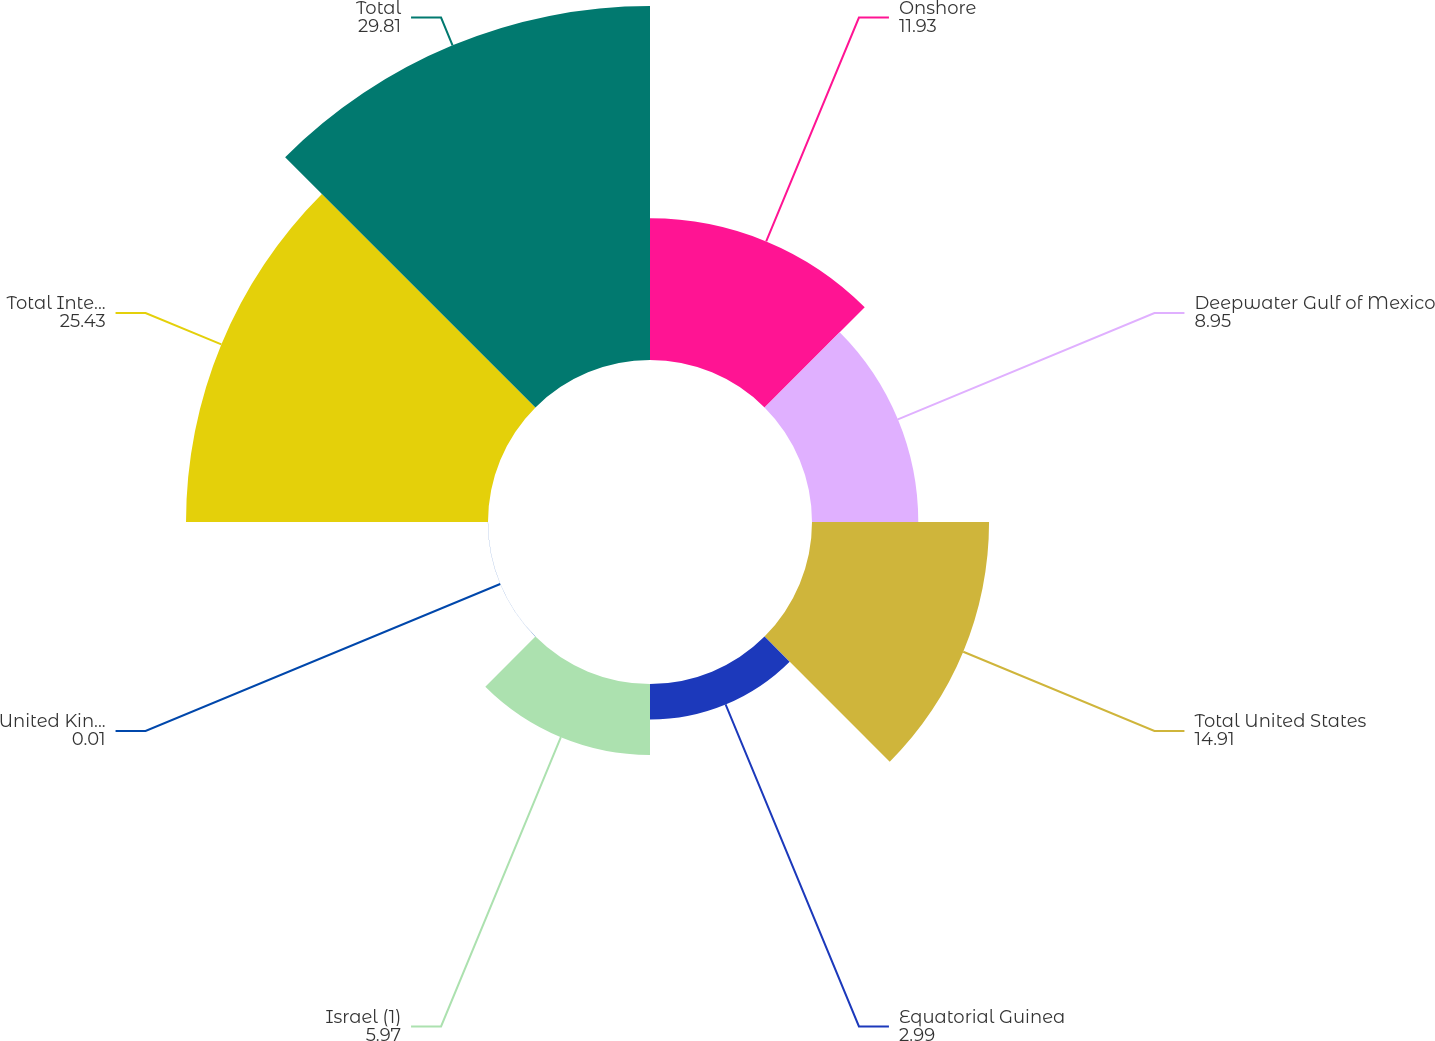Convert chart. <chart><loc_0><loc_0><loc_500><loc_500><pie_chart><fcel>Onshore<fcel>Deepwater Gulf of Mexico<fcel>Total United States<fcel>Equatorial Guinea<fcel>Israel (1)<fcel>United Kingdom<fcel>Total International<fcel>Total<nl><fcel>11.93%<fcel>8.95%<fcel>14.91%<fcel>2.99%<fcel>5.97%<fcel>0.01%<fcel>25.43%<fcel>29.81%<nl></chart> 